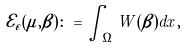<formula> <loc_0><loc_0><loc_500><loc_500>\mathcal { E } _ { \varepsilon } ( \mu , \beta ) \colon = \int _ { \Omega } W ( \beta ) d x ,</formula> 